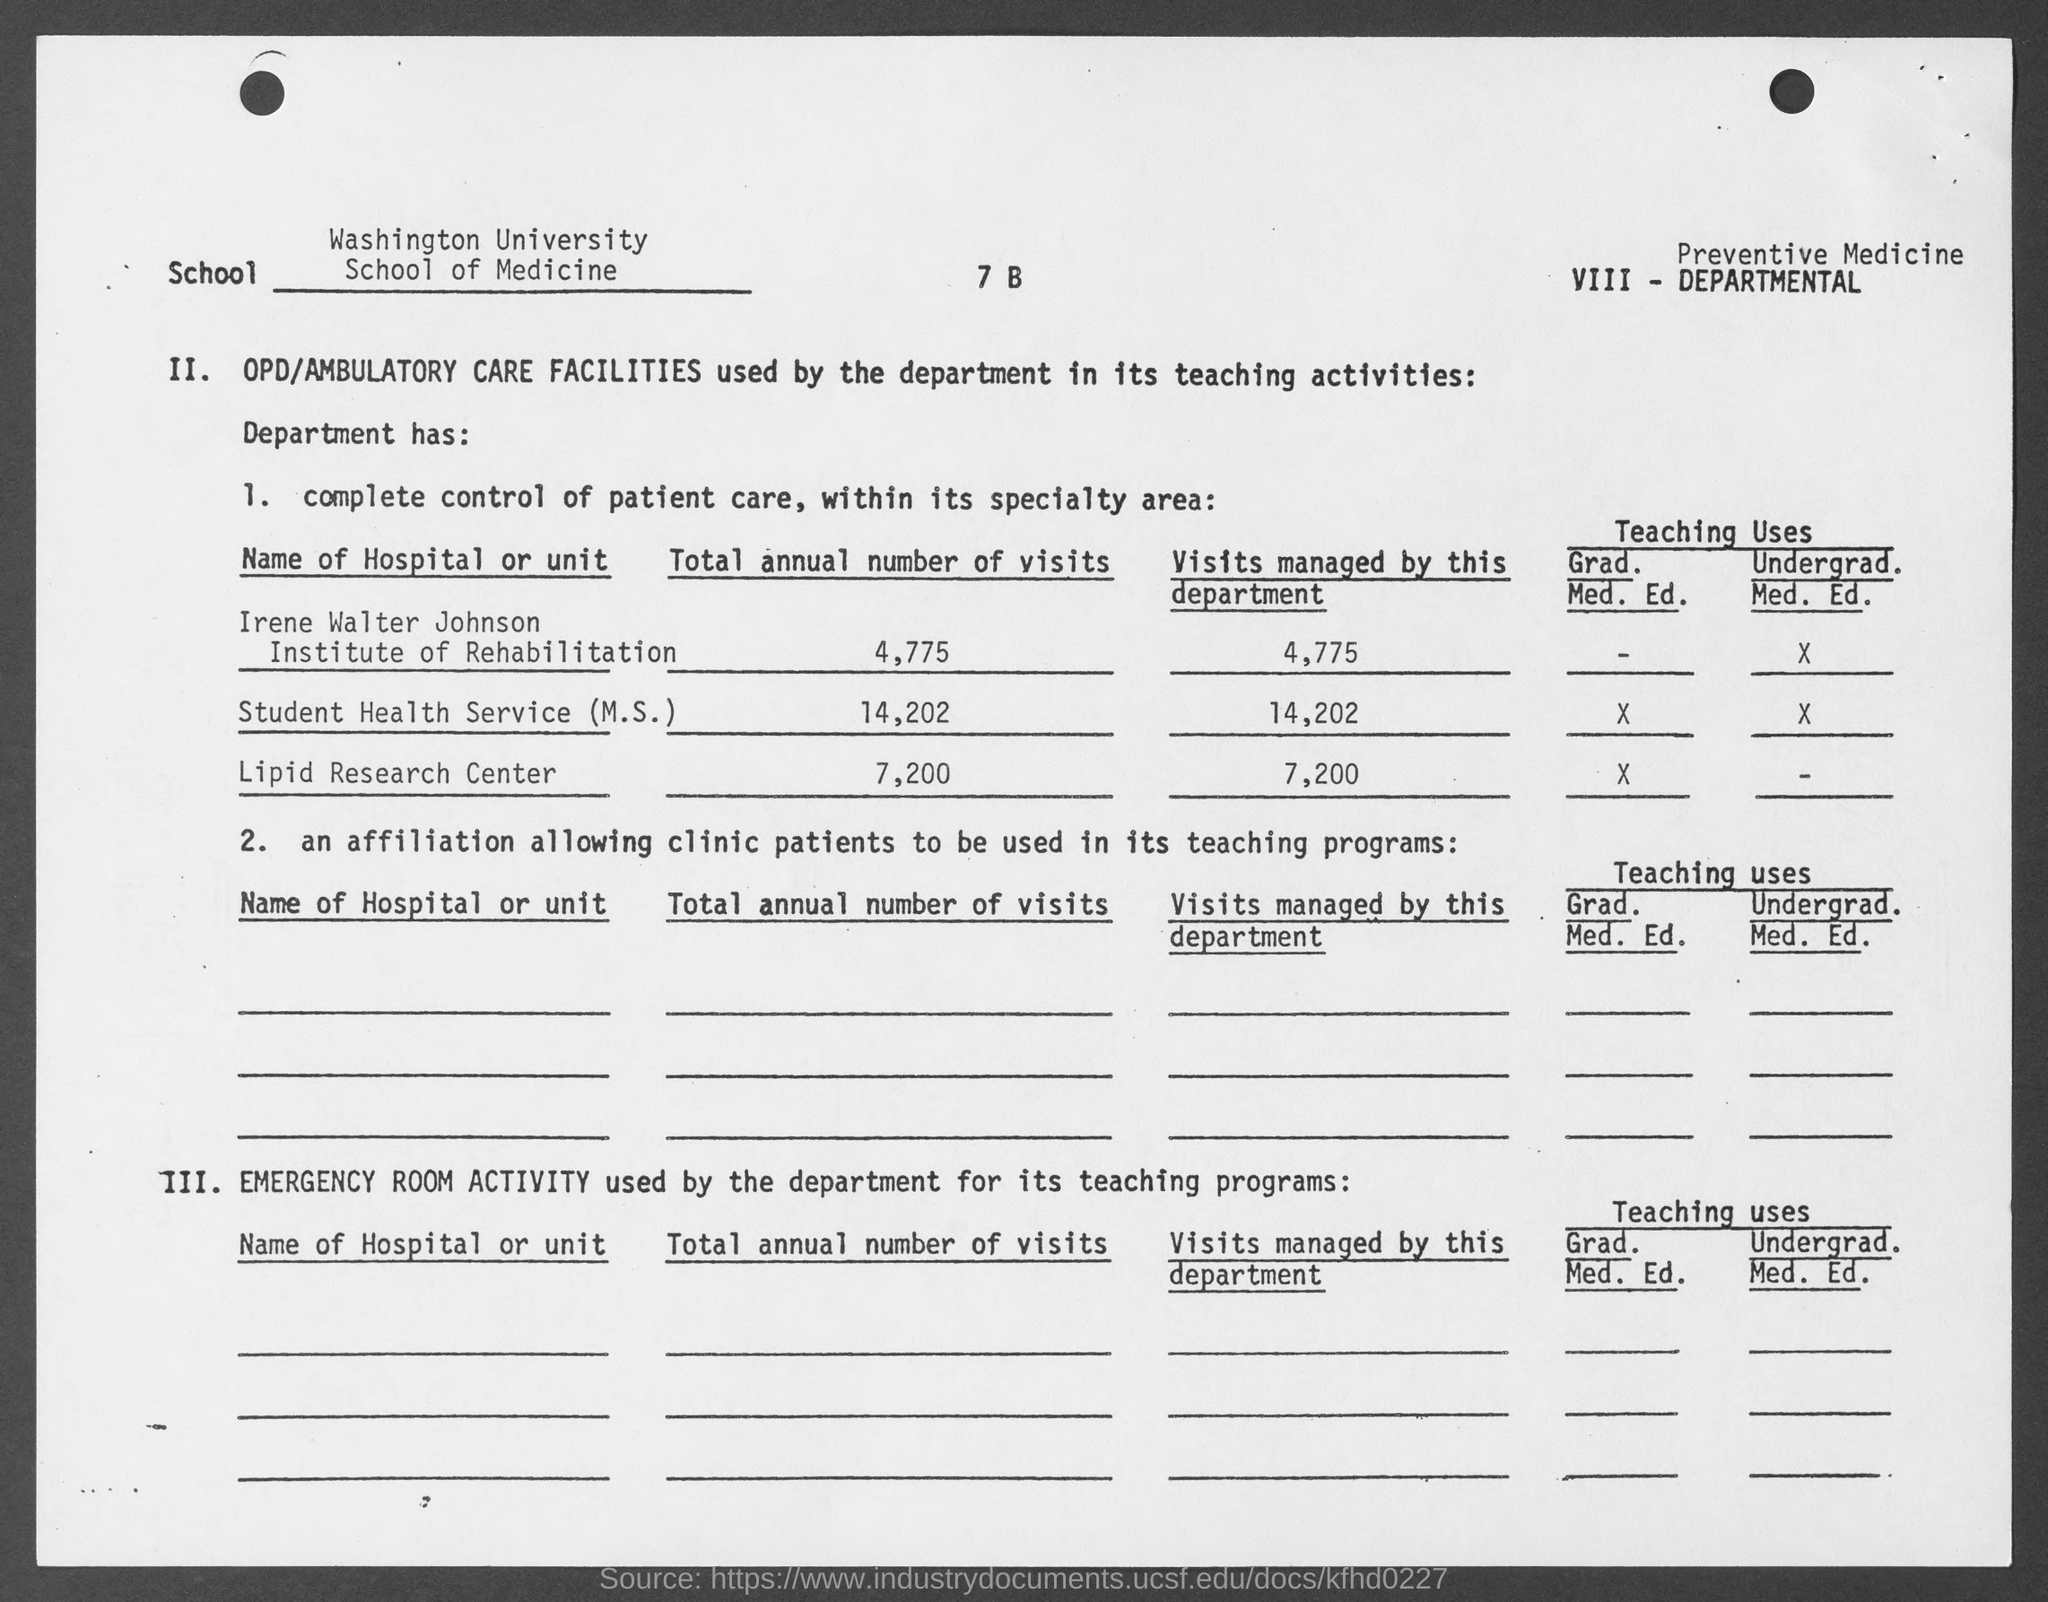What is the name of the school mentioned in the given page ?
Ensure brevity in your answer.  School of medicine. What is the name of the university mentioned in the given form ?
Give a very brief answer. Washington university. What is the total annual number of visits for irene walter johnson institute of rehabilitation as mentioned in the given page ?
Offer a very short reply. 4,775. What is the total annual number of visits for student health service (m.s.) as mentioned in the given page ?
Your answer should be very brief. 14,202. What is the total annual number of visits for lipid research center as mentioned in the given page ?
Offer a terse response. 7,200. 